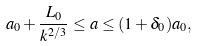Convert formula to latex. <formula><loc_0><loc_0><loc_500><loc_500>a _ { 0 } + \frac { L _ { 0 } } { k ^ { 2 / 3 } } \leq a \leq ( 1 + \delta _ { 0 } ) a _ { 0 } ,</formula> 